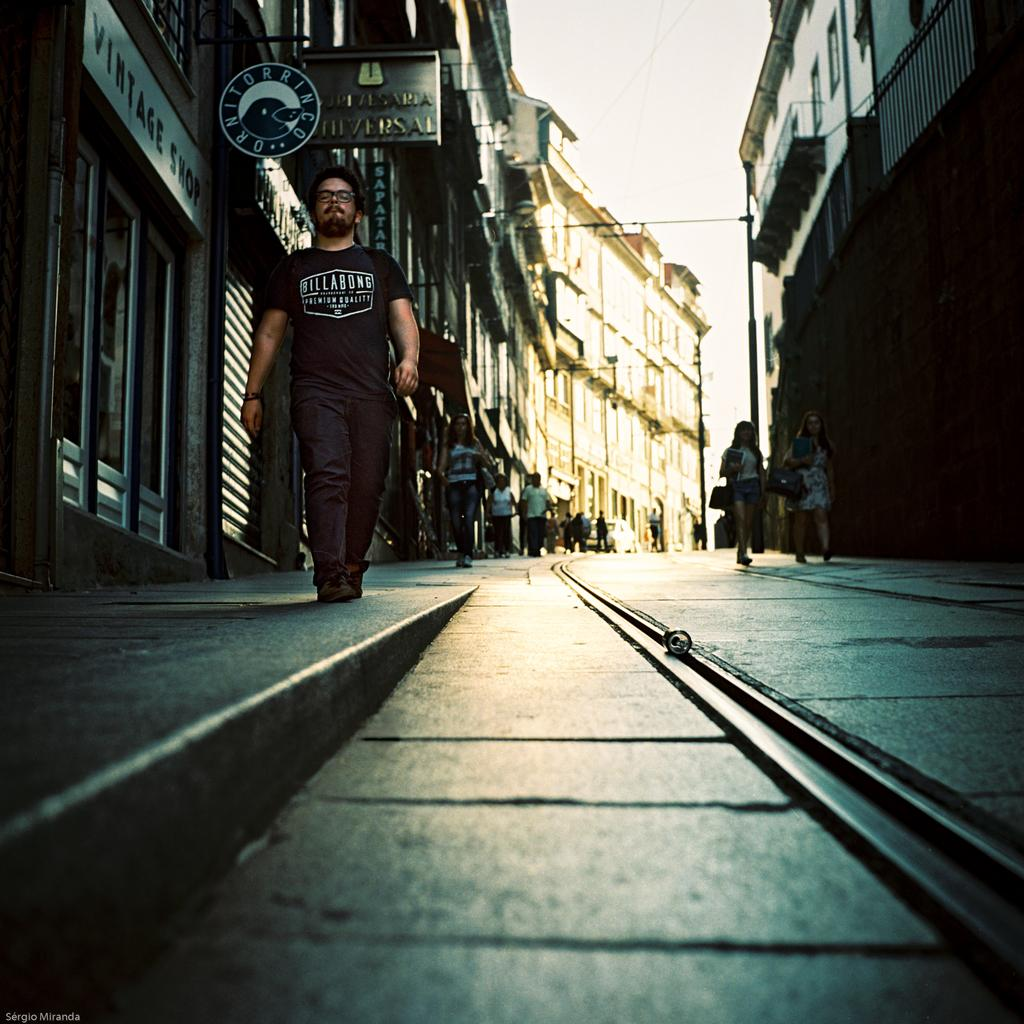What is happening on the ground in the image? There are people on the ground in the image. What type of structures can be seen in the image? There are buildings visible in the image. Can you describe any other items or objects in the image? Yes, there are some objects in the image. What can be seen in the background of the image? The sky is visible in the background of the image. How many ants are crawling on the gate in the image? There are no ants or gates present in the image. What type of yard is visible in the image? There is no yard visible in the image; it features people, buildings, and objects. 